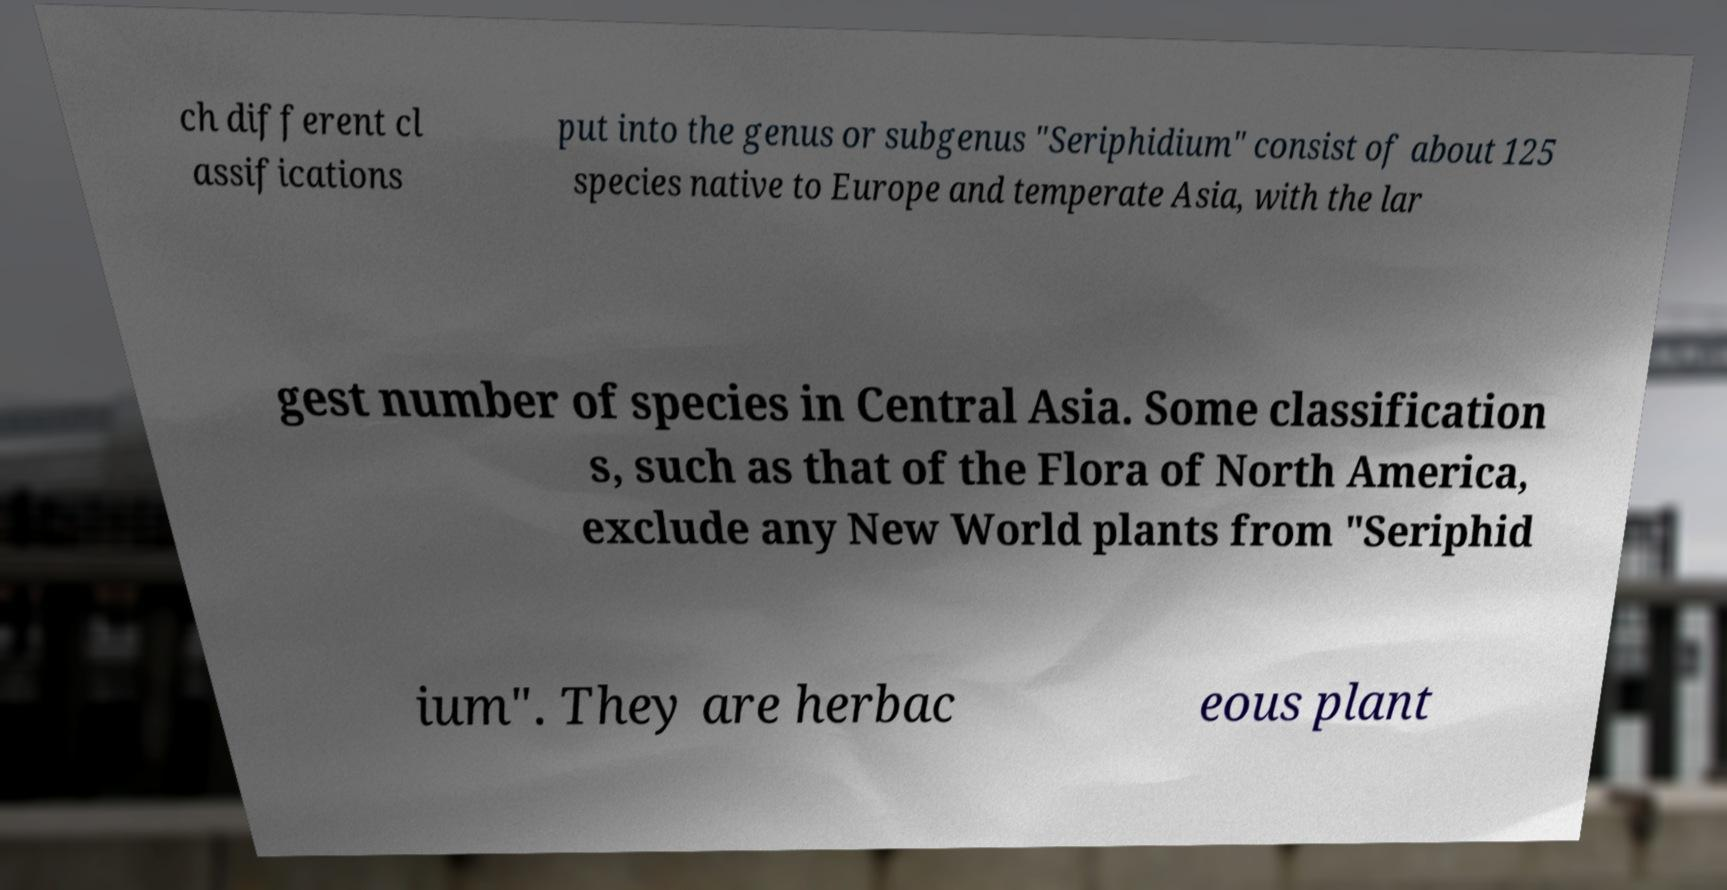Could you extract and type out the text from this image? ch different cl assifications put into the genus or subgenus "Seriphidium" consist of about 125 species native to Europe and temperate Asia, with the lar gest number of species in Central Asia. Some classification s, such as that of the Flora of North America, exclude any New World plants from "Seriphid ium". They are herbac eous plant 